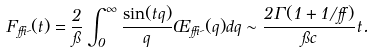Convert formula to latex. <formula><loc_0><loc_0><loc_500><loc_500>F _ { \delta \psi } ( t ) = \frac { 2 } { \pi } \int _ { 0 } ^ { \infty } \frac { \sin ( t q ) } { q } \phi _ { \delta \psi } ( q ) d q \sim \frac { 2 \Gamma ( 1 + 1 / \alpha ) } { \pi c } t .</formula> 